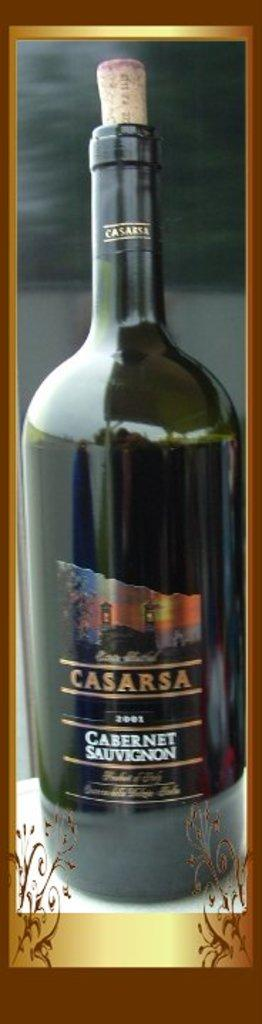<image>
Provide a brief description of the given image. A bottle of Casarsa Cabernet Sauvignon wine from 2001. 